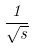Convert formula to latex. <formula><loc_0><loc_0><loc_500><loc_500>\frac { 1 } { \sqrt { s } }</formula> 